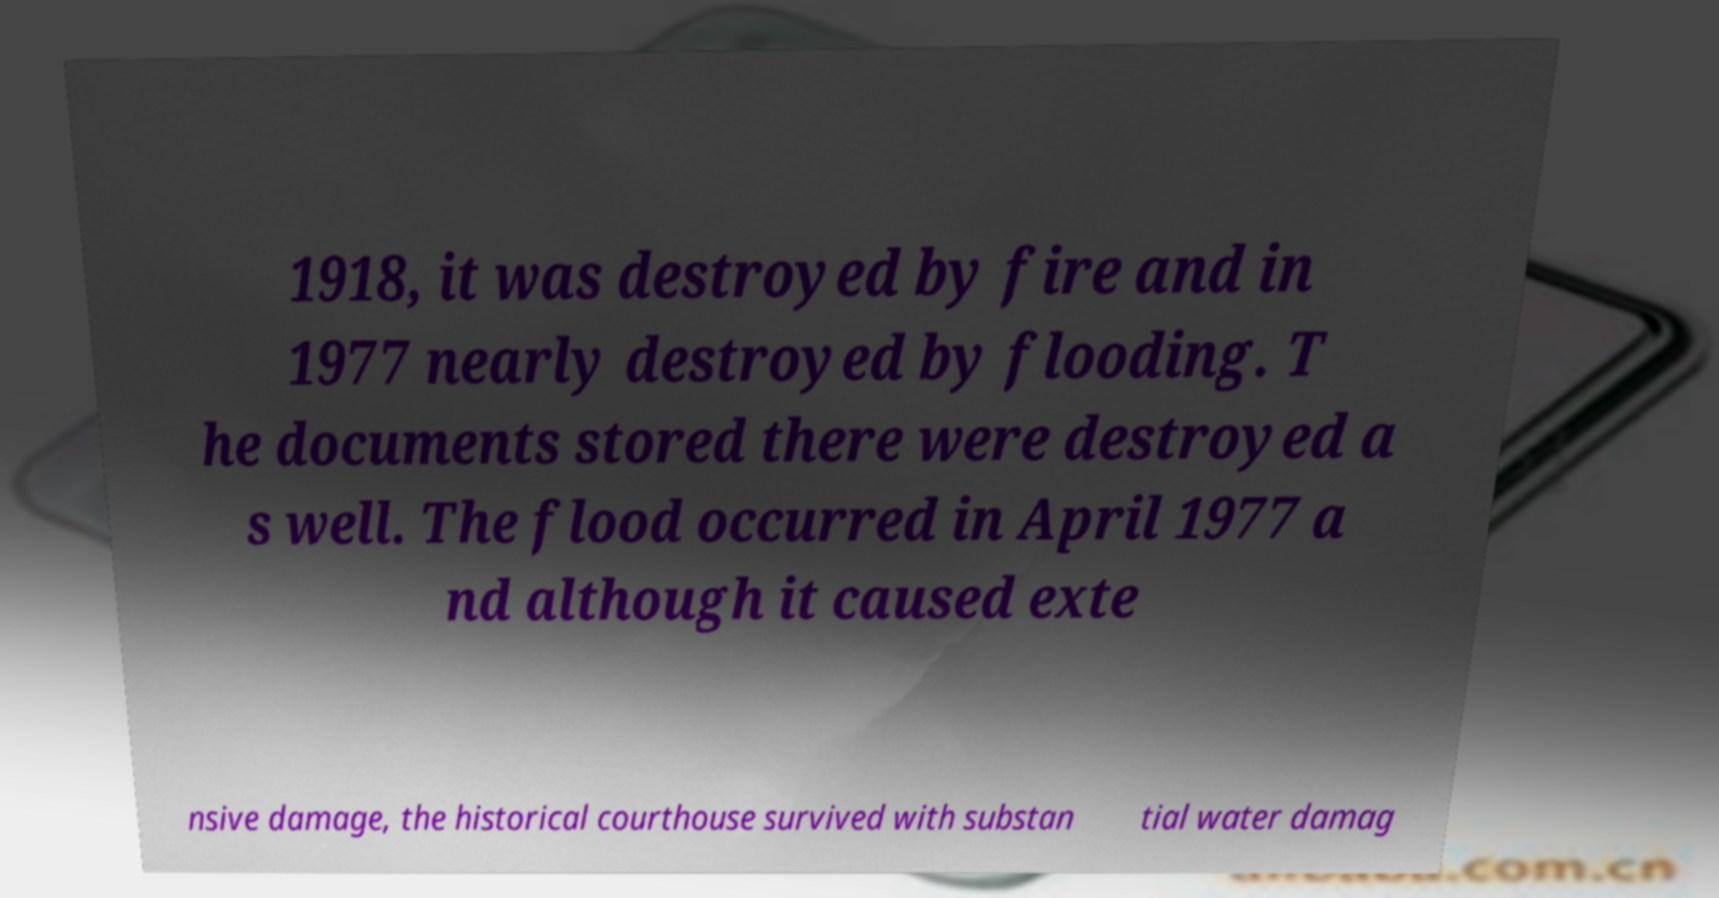I need the written content from this picture converted into text. Can you do that? 1918, it was destroyed by fire and in 1977 nearly destroyed by flooding. T he documents stored there were destroyed a s well. The flood occurred in April 1977 a nd although it caused exte nsive damage, the historical courthouse survived with substan tial water damag 